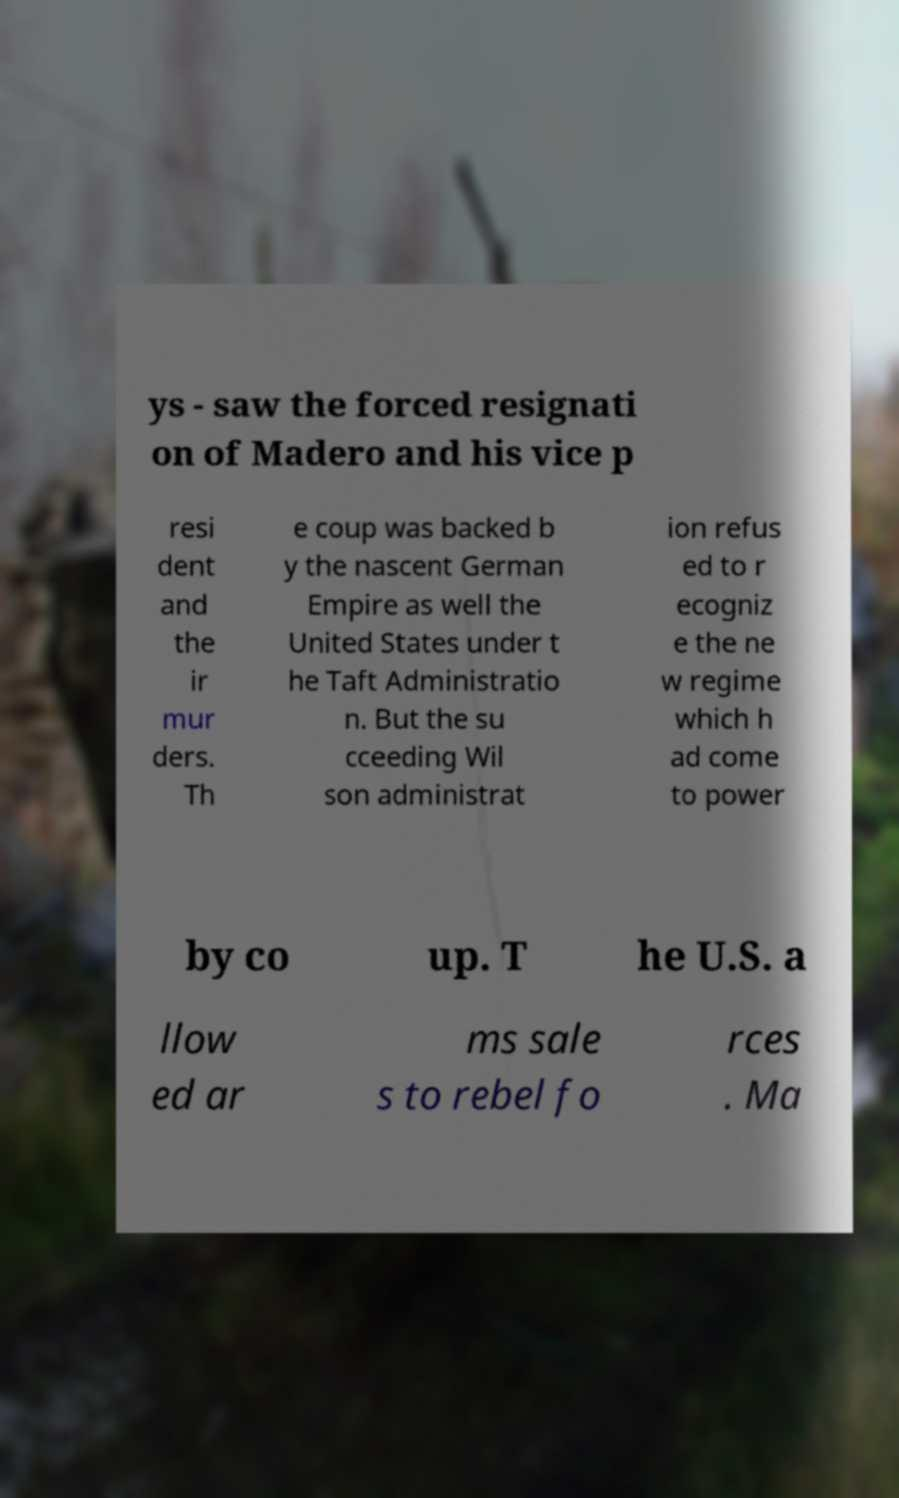Could you extract and type out the text from this image? ys - saw the forced resignati on of Madero and his vice p resi dent and the ir mur ders. Th e coup was backed b y the nascent German Empire as well the United States under t he Taft Administratio n. But the su cceeding Wil son administrat ion refus ed to r ecogniz e the ne w regime which h ad come to power by co up. T he U.S. a llow ed ar ms sale s to rebel fo rces . Ma 